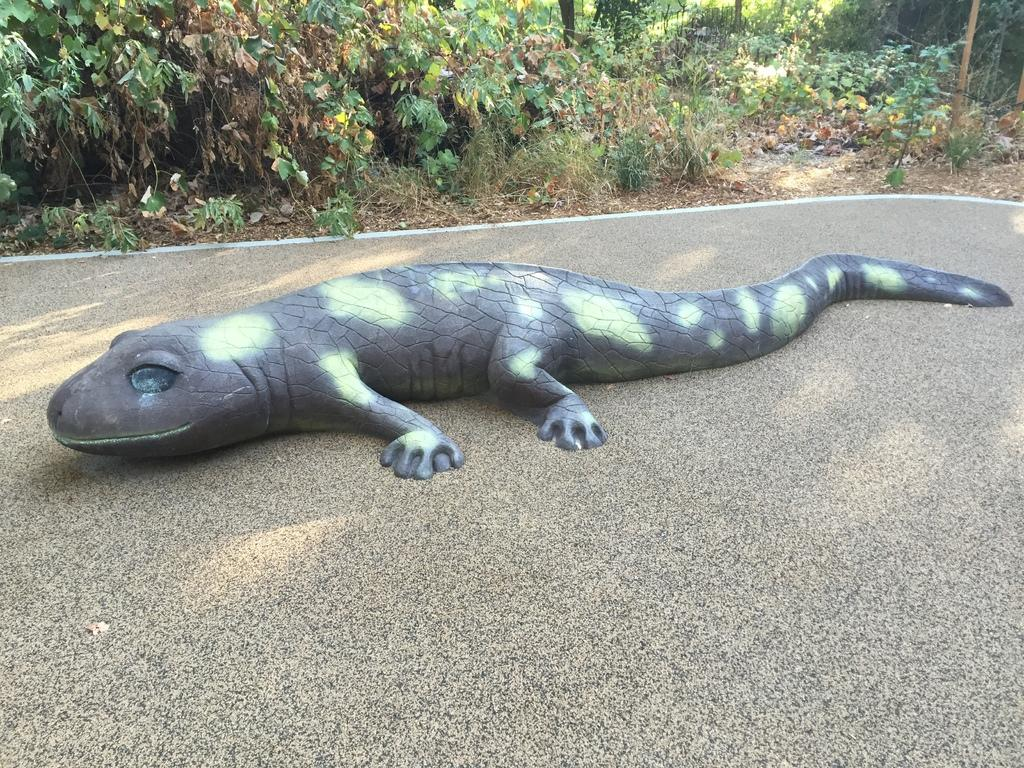What object is on the road in the image? There is a reptile toy on the road in the image. What can be seen in the background of the image? Planets are visible in the background of the image. Where is the harbor located in the image? There is no harbor present in the image. What type of notebook is being used by the reptile toy in the image? There is no notebook present in the image, as it features a reptile toy on the road and planets in the background. 